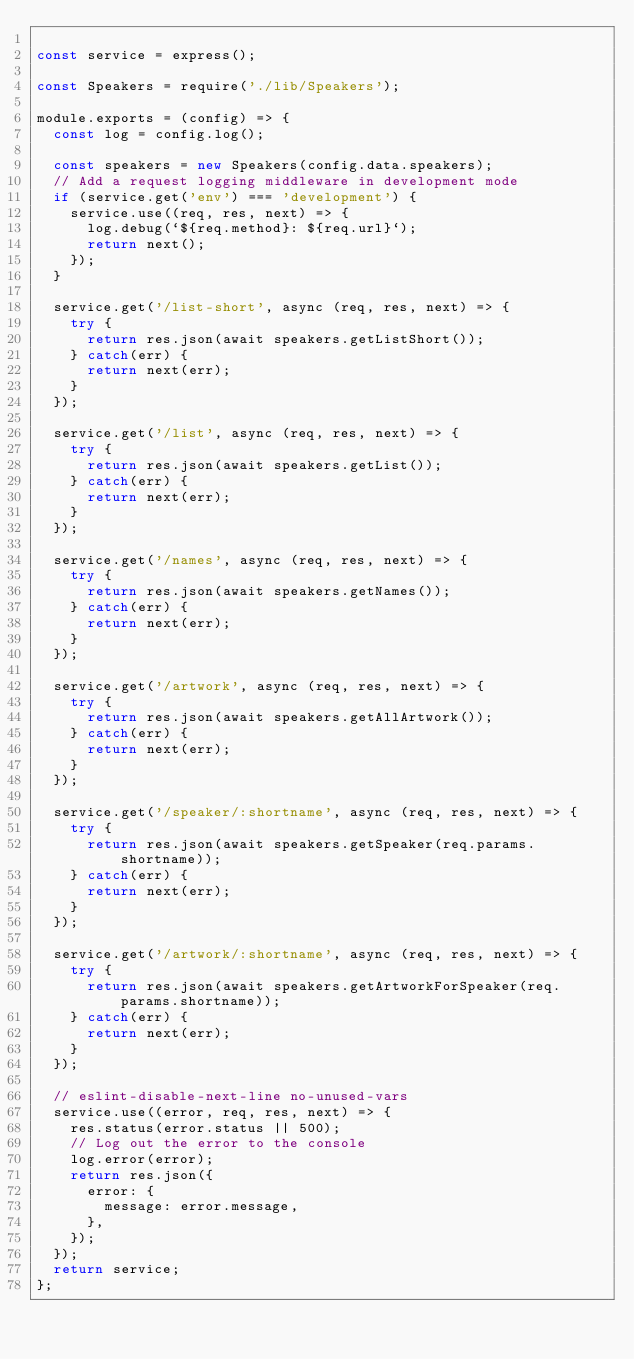Convert code to text. <code><loc_0><loc_0><loc_500><loc_500><_JavaScript_>
const service = express();

const Speakers = require('./lib/Speakers');

module.exports = (config) => {
  const log = config.log();

  const speakers = new Speakers(config.data.speakers);
  // Add a request logging middleware in development mode
  if (service.get('env') === 'development') {
    service.use((req, res, next) => {
      log.debug(`${req.method}: ${req.url}`);
      return next();
    });
  }

  service.get('/list-short', async (req, res, next) => {
    try {
      return res.json(await speakers.getListShort());
    } catch(err) {
      return next(err);
    }
  });

  service.get('/list', async (req, res, next) => {
    try {
      return res.json(await speakers.getList());
    } catch(err) {
      return next(err);
    }
  });

  service.get('/names', async (req, res, next) => {
    try {
      return res.json(await speakers.getNames());
    } catch(err) {
      return next(err);
    }
  });

  service.get('/artwork', async (req, res, next) => {
    try {
      return res.json(await speakers.getAllArtwork());
    } catch(err) {
      return next(err);
    }
  });

  service.get('/speaker/:shortname', async (req, res, next) => {
    try {
      return res.json(await speakers.getSpeaker(req.params.shortname));
    } catch(err) {
      return next(err);
    }
  });

  service.get('/artwork/:shortname', async (req, res, next) => {
    try {
      return res.json(await speakers.getArtworkForSpeaker(req.params.shortname));
    } catch(err) {
      return next(err);
    }
  });

  // eslint-disable-next-line no-unused-vars
  service.use((error, req, res, next) => {
    res.status(error.status || 500);
    // Log out the error to the console
    log.error(error);
    return res.json({
      error: {
        message: error.message,
      },
    });
  });
  return service;
};
</code> 